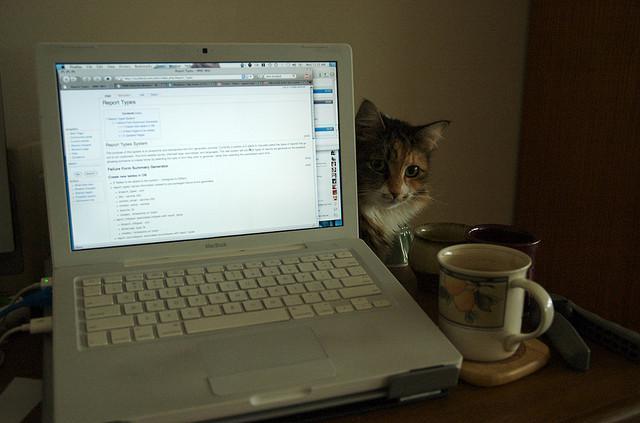How many mugs are on the table?
Give a very brief answer. 3. How many keyboards can be seen?
Give a very brief answer. 1. How many screens are being used?
Give a very brief answer. 1. How many monitors are in the image?
Give a very brief answer. 1. How many computers are there?
Give a very brief answer. 1. How many electronic devices are there?
Give a very brief answer. 1. How many computers are on the desk?
Give a very brief answer. 1. How many keyboards are visible?
Give a very brief answer. 1. How many cats are on the keyboard?
Give a very brief answer. 0. How many laptops are on the table?
Give a very brief answer. 1. How many cups?
Give a very brief answer. 3. How many pens in the cup?
Give a very brief answer. 0. How many cups are there?
Give a very brief answer. 3. 